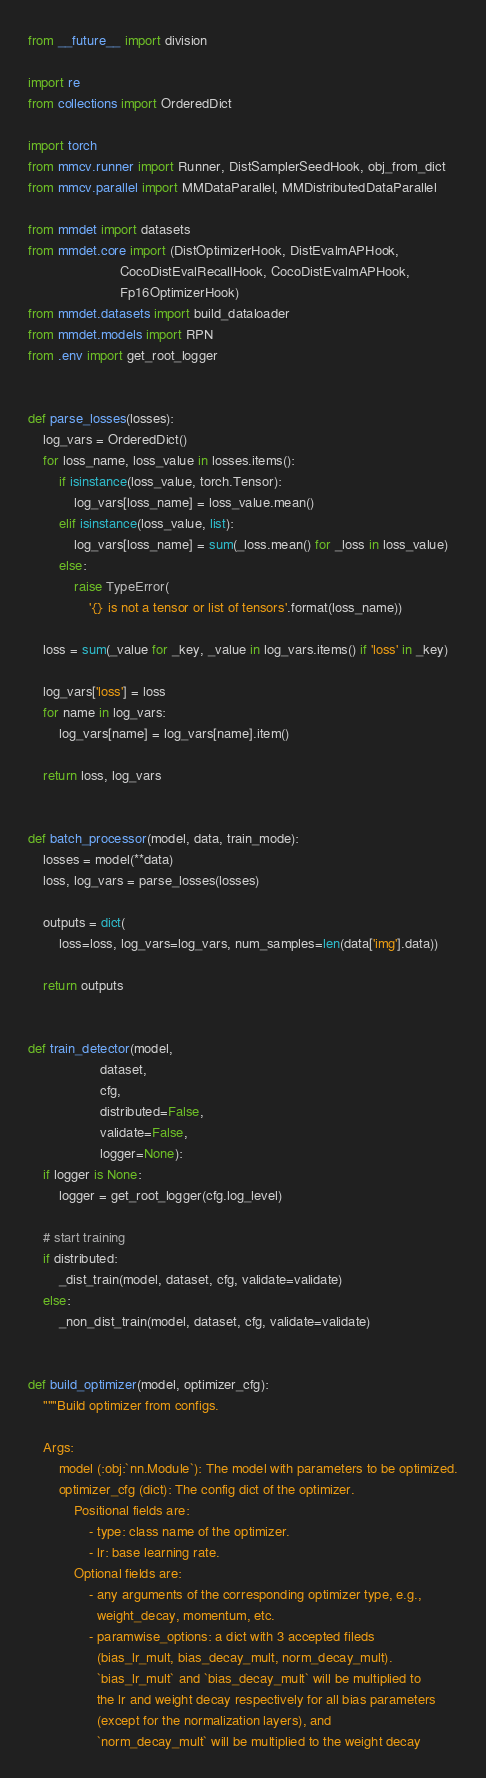<code> <loc_0><loc_0><loc_500><loc_500><_Python_>from __future__ import division

import re
from collections import OrderedDict

import torch
from mmcv.runner import Runner, DistSamplerSeedHook, obj_from_dict
from mmcv.parallel import MMDataParallel, MMDistributedDataParallel

from mmdet import datasets
from mmdet.core import (DistOptimizerHook, DistEvalmAPHook,
                        CocoDistEvalRecallHook, CocoDistEvalmAPHook,
                        Fp16OptimizerHook)
from mmdet.datasets import build_dataloader
from mmdet.models import RPN
from .env import get_root_logger


def parse_losses(losses):
    log_vars = OrderedDict()
    for loss_name, loss_value in losses.items():
        if isinstance(loss_value, torch.Tensor):
            log_vars[loss_name] = loss_value.mean()
        elif isinstance(loss_value, list):
            log_vars[loss_name] = sum(_loss.mean() for _loss in loss_value)
        else:
            raise TypeError(
                '{} is not a tensor or list of tensors'.format(loss_name))

    loss = sum(_value for _key, _value in log_vars.items() if 'loss' in _key)

    log_vars['loss'] = loss
    for name in log_vars:
        log_vars[name] = log_vars[name].item()

    return loss, log_vars


def batch_processor(model, data, train_mode):
    losses = model(**data)
    loss, log_vars = parse_losses(losses)

    outputs = dict(
        loss=loss, log_vars=log_vars, num_samples=len(data['img'].data))

    return outputs


def train_detector(model,
                   dataset,
                   cfg,
                   distributed=False,
                   validate=False,
                   logger=None):
    if logger is None:
        logger = get_root_logger(cfg.log_level)

    # start training
    if distributed:
        _dist_train(model, dataset, cfg, validate=validate)
    else:
        _non_dist_train(model, dataset, cfg, validate=validate)


def build_optimizer(model, optimizer_cfg):
    """Build optimizer from configs.

    Args:
        model (:obj:`nn.Module`): The model with parameters to be optimized.
        optimizer_cfg (dict): The config dict of the optimizer.
            Positional fields are:
                - type: class name of the optimizer.
                - lr: base learning rate.
            Optional fields are:
                - any arguments of the corresponding optimizer type, e.g.,
                  weight_decay, momentum, etc.
                - paramwise_options: a dict with 3 accepted fileds
                  (bias_lr_mult, bias_decay_mult, norm_decay_mult).
                  `bias_lr_mult` and `bias_decay_mult` will be multiplied to
                  the lr and weight decay respectively for all bias parameters
                  (except for the normalization layers), and
                  `norm_decay_mult` will be multiplied to the weight decay</code> 